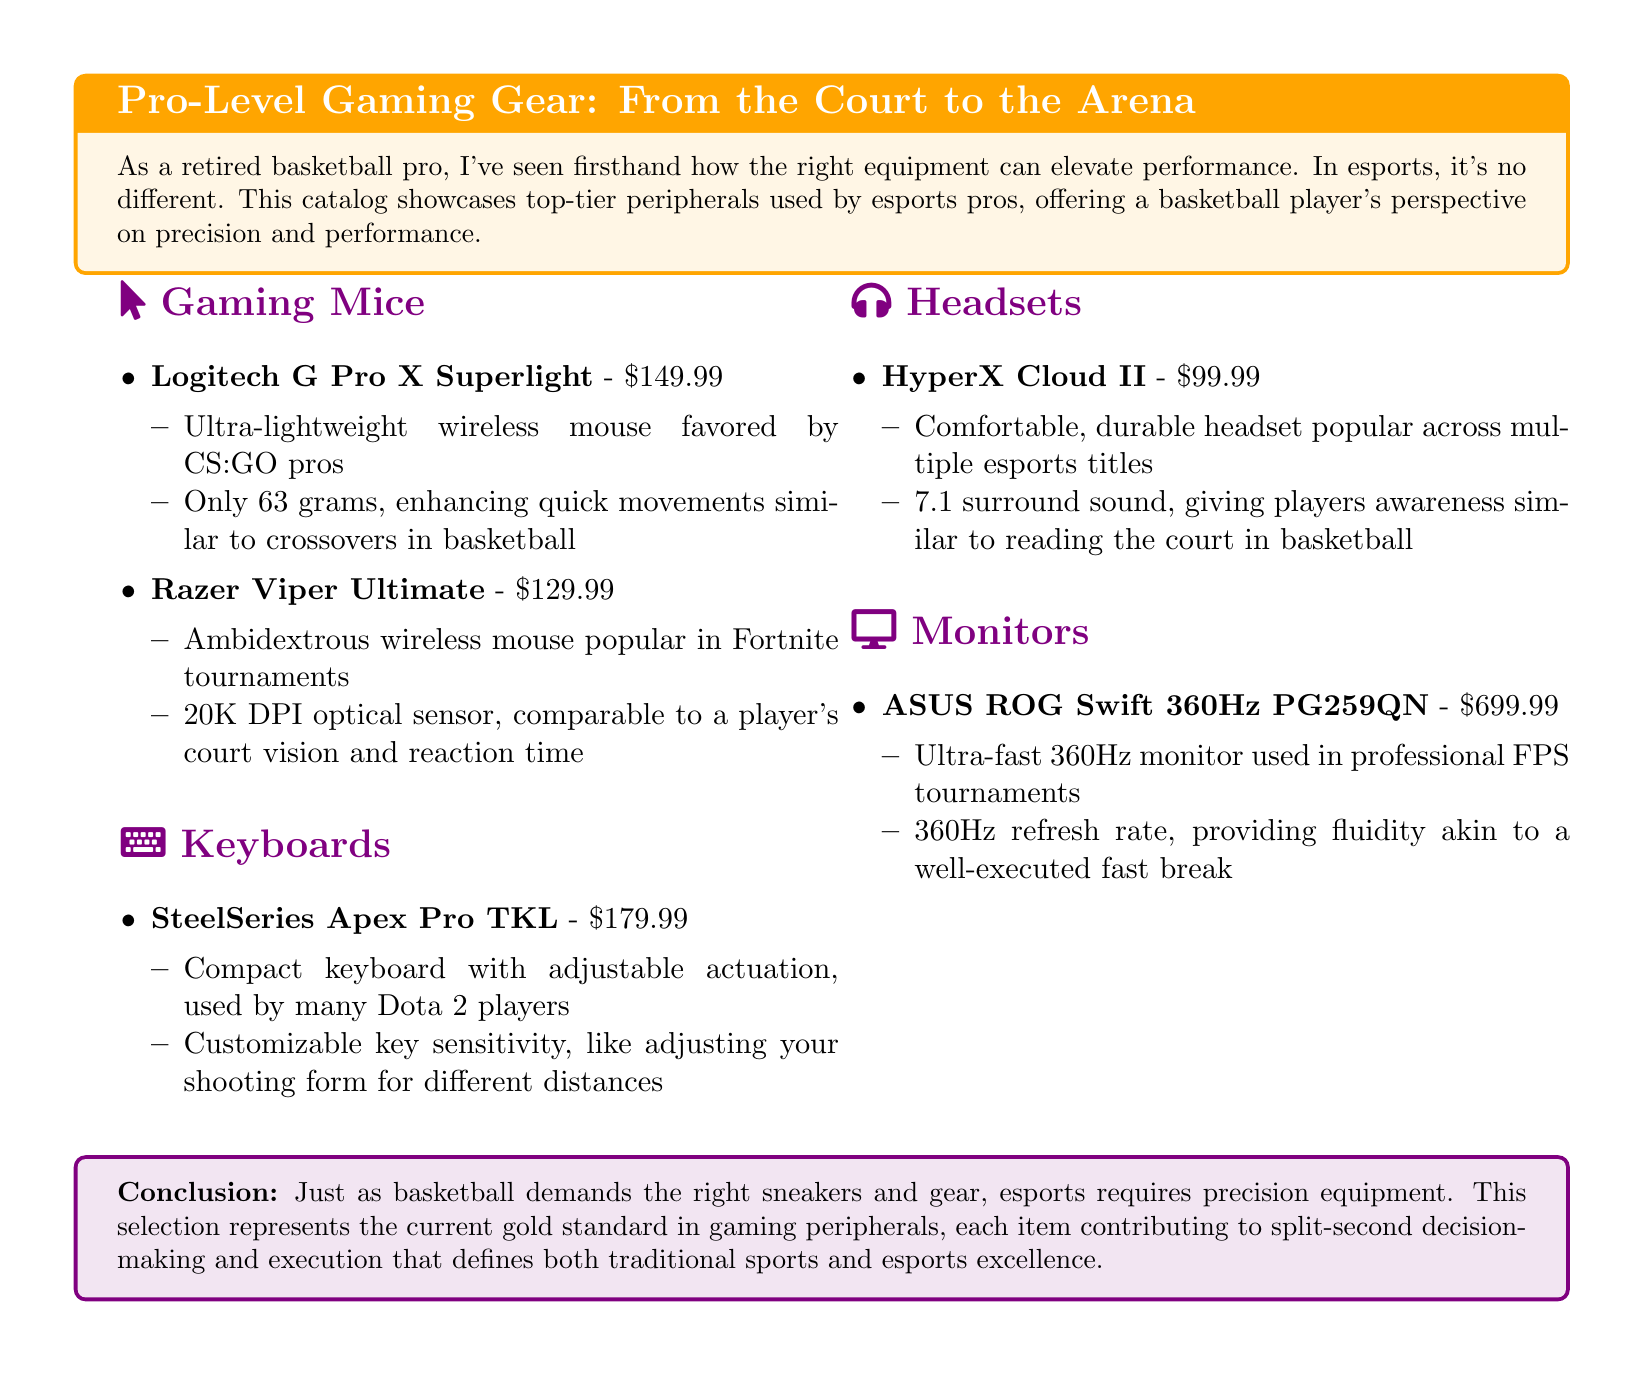What is the weight of the Logitech G Pro X Superlight? The weight of the Logitech G Pro X Superlight is highlighted as a key feature, which is 63 grams.
Answer: 63 grams What is the price of the SteelSeries Apex Pro TKL? The SteelSeries Apex Pro TKL is listed with a price point in the document of $179.99.
Answer: $179.99 Which mouse is popular in Fortnite tournaments? The document specifies that the Razer Viper Ultimate is popular in Fortnite tournaments.
Answer: Razer Viper Ultimate What feature does the HyperX Cloud II headset offer? The document mentions that the HyperX Cloud II offers 7.1 surround sound as a notable feature.
Answer: 7.1 surround sound How does the refresh rate of the ASUS ROG Swift compare to traditional monitors? The document states that the ASUS ROG Swift has an ultra-fast 360Hz refresh rate, which is superior to traditional monitors.
Answer: 360Hz Which esports title is the SteelSeries Apex Pro TKL associated with? The SteelSeries Apex Pro TKL is used by many Dota 2 players, according to the document.
Answer: Dota 2 What type of gaming gear does the document focus on? The document focuses on pro-level gaming peripherals and equipment used by esports players.
Answer: Pro-level gaming peripherals What is the main comparison drawn between gaming equipment and basketball? The document draws parallels between performance on the court and in esports, emphasizing that both require precision equipment.
Answer: Precision equipment 